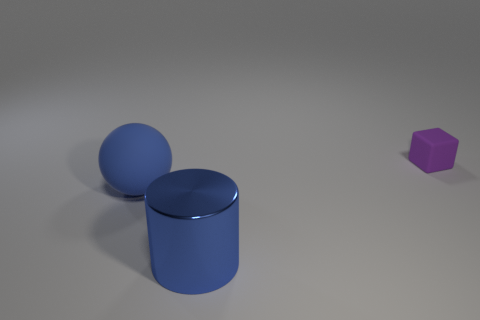Is there any indication of light source direction in the image? Yes, based on the shadows present, the light source appears to be coming from the upper left side of the image, casting shadows diagonally toward the bottom right.  How does the lighting affect the mood of the scene? The lighting creates a soft and diffused atmosphere with subtle shadows, which gives a calm and neutral mood to the scene. The absence of harsh shadows or highlights suggests an even and perhaps artificial light source. 